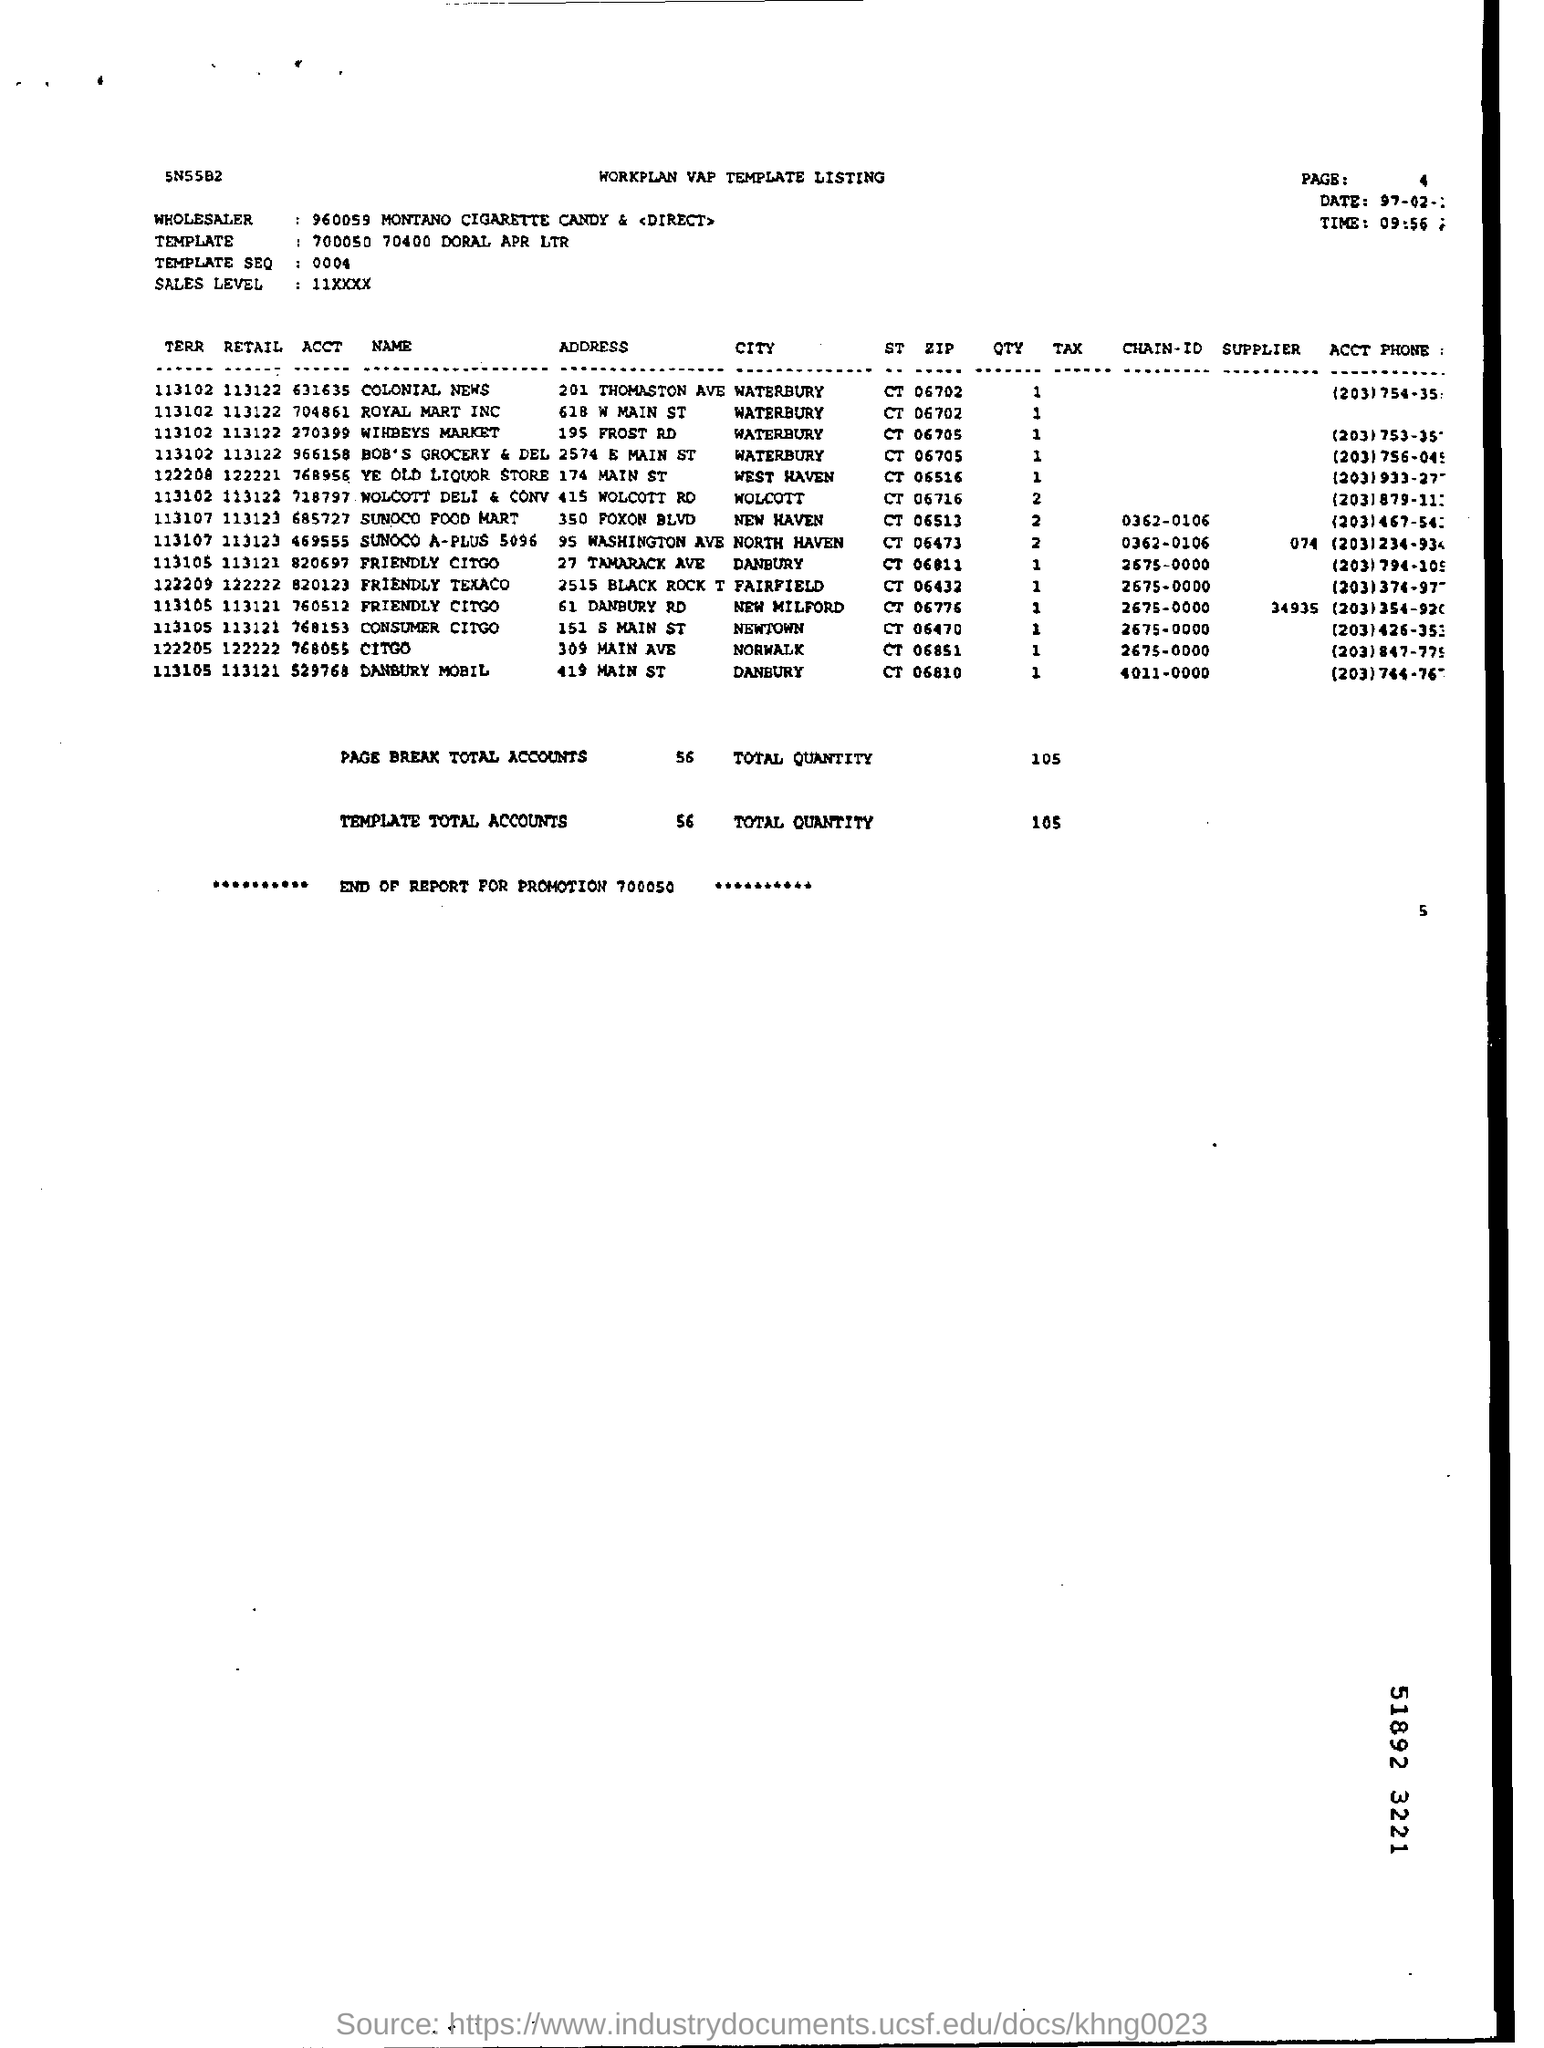Specify some key components in this picture. The total number of accounts is 56. The time mentioned is 9:56. The total number of page breaks for accounts is 56. The name of the wholesaler is Montano Cigarette Candy & Direct. 